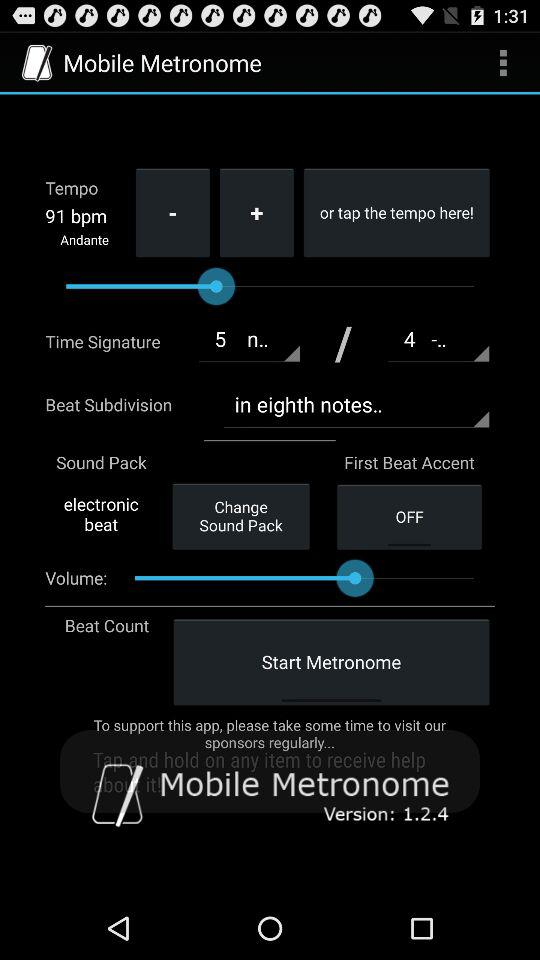How many more bpm is the tempo of this metronome than 60 bpm?
Answer the question using a single word or phrase. 31 